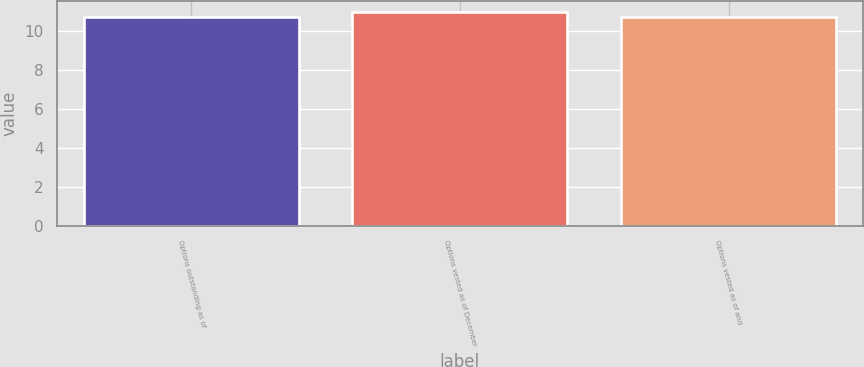Convert chart. <chart><loc_0><loc_0><loc_500><loc_500><bar_chart><fcel>Options outstanding as of<fcel>Options vested as of December<fcel>Options vested as of and<nl><fcel>10.71<fcel>11<fcel>10.74<nl></chart> 